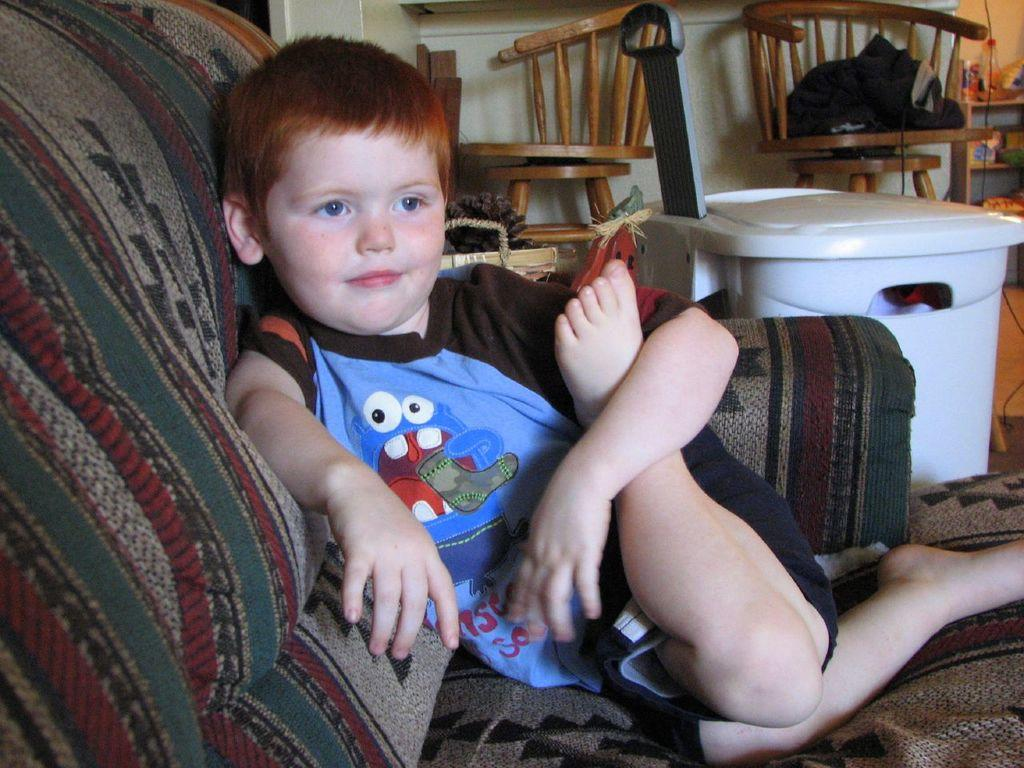What is the kid doing in the image? The kid is sitting in the sofa. What color is the object visible in the image? There is a white color object in the image. How many chairs can be seen in the background? There are two chairs in the background. What else can be seen in the background besides the chairs? There are other objects present in the background. What type of pie is being served on the flight in the image? There is no flight or pie present in the image; it features a kid sitting on a sofa and a white object. What adjustment needs to be made to the sofa for the kid to be more comfortable? The image does not provide information about the kid's comfort or any adjustments needed for the sofa. 